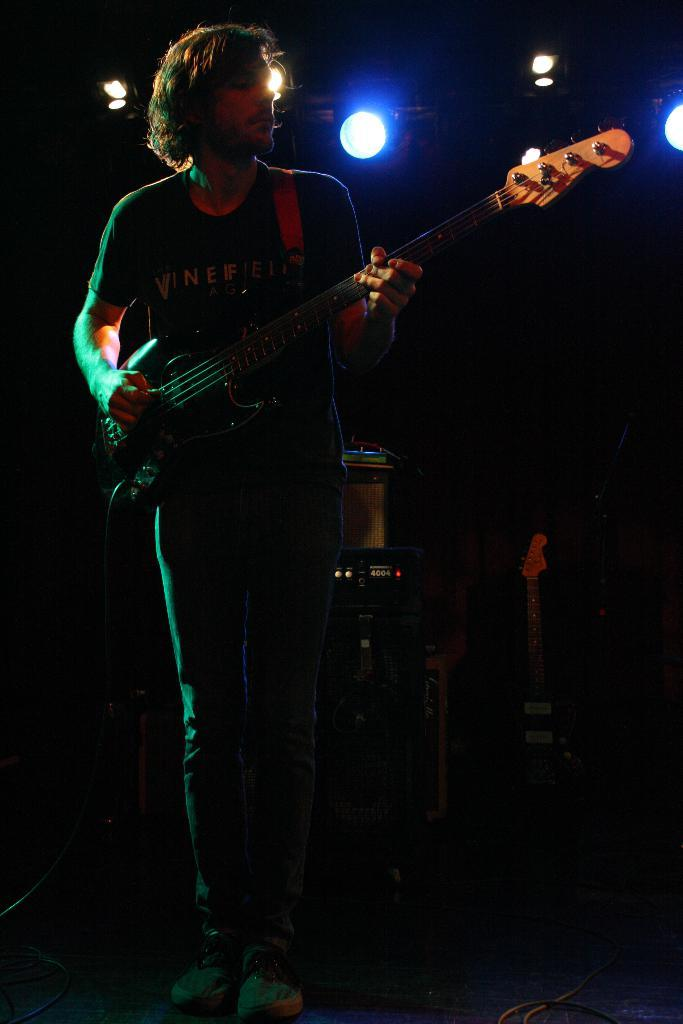What is the man in the image doing? The man is playing a guitar in the image. Can you describe the setting of the image? There are lights visible in the background of the image. How many mittens can be seen on the man's hands in the image? There are no mittens present in the image. 